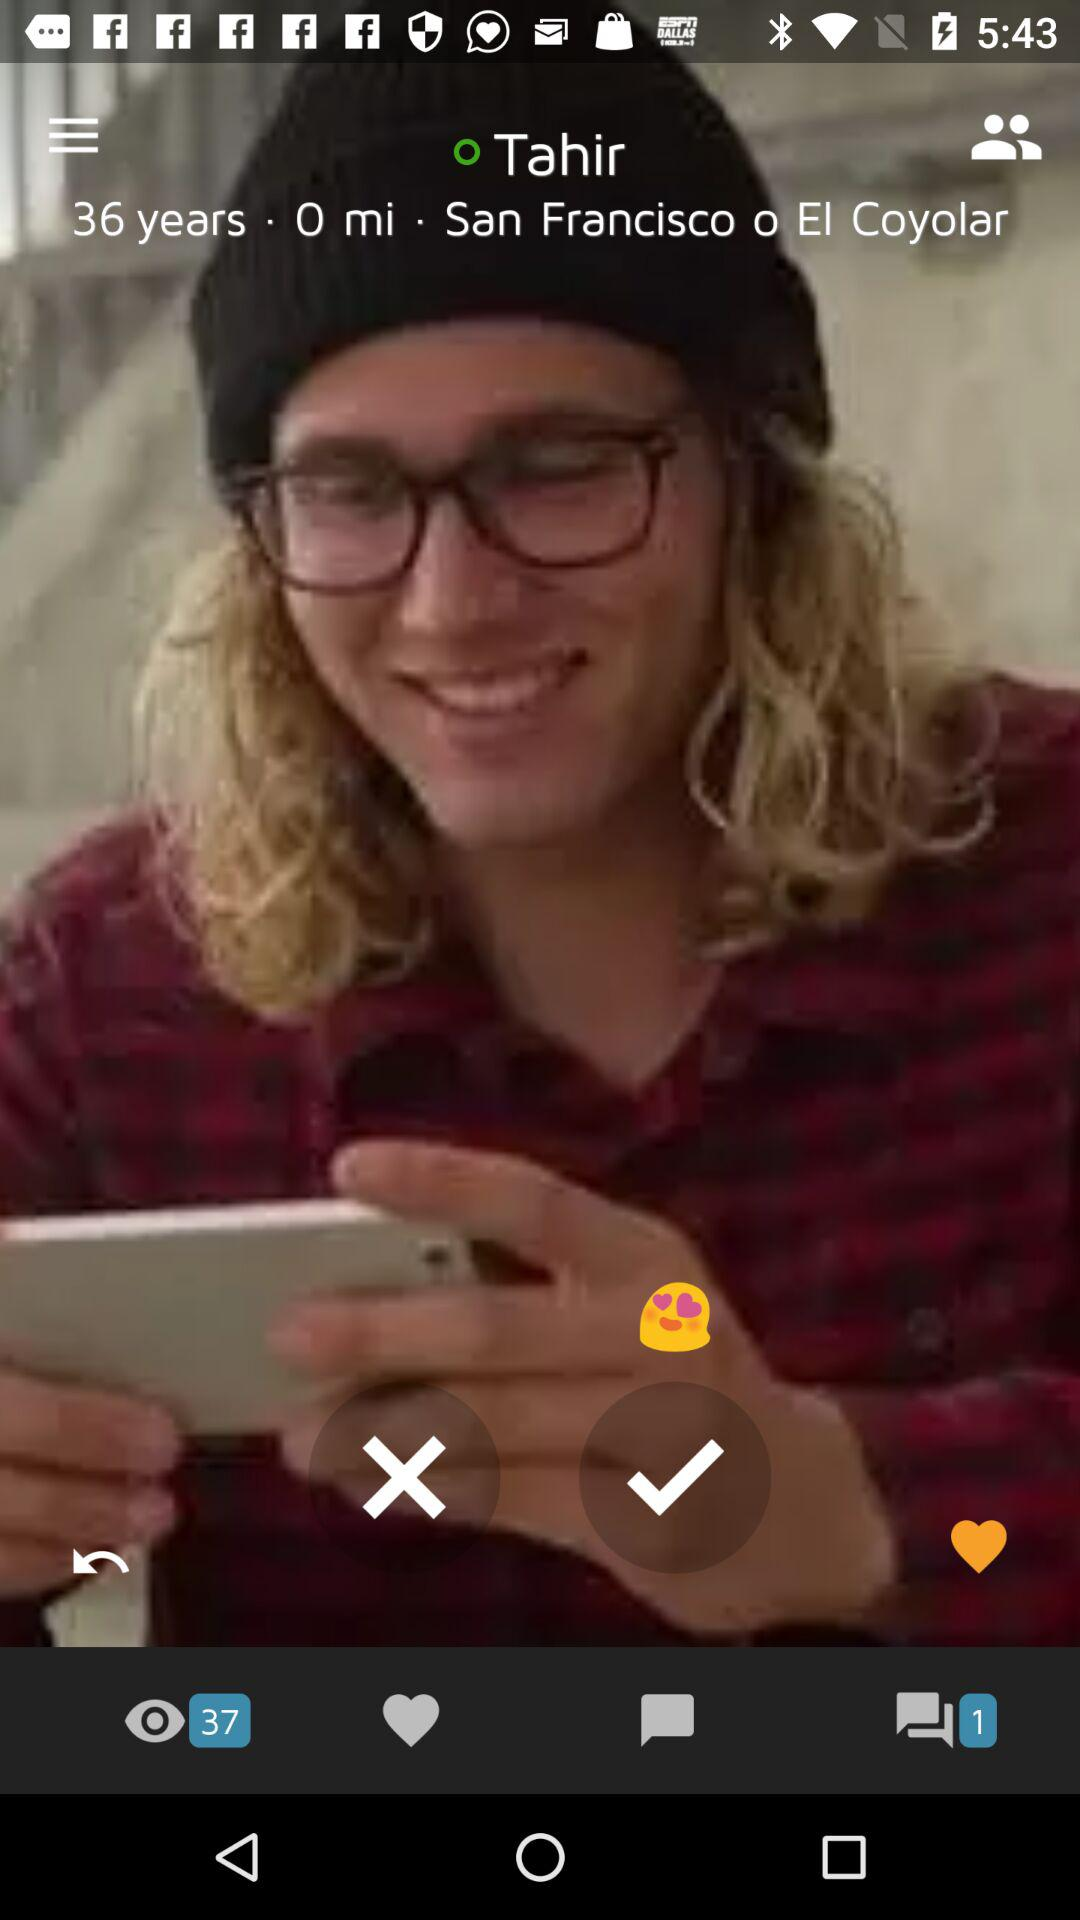What is the address of Tahir? The address is San Francisco o El Coyolar. 